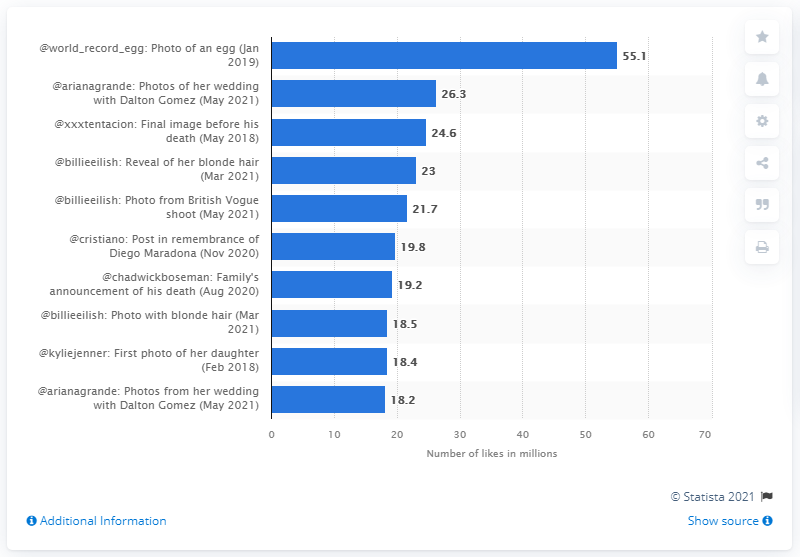Point out several critical features in this image. As of June 2021, the photo of Kylie Jenner's daughter Stormi had 55.1 likes. According to data, the wedding photos of Ariana Grande generated 26.3 likes on Instagram. 